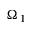Convert formula to latex. <formula><loc_0><loc_0><loc_500><loc_500>\Omega _ { 1 }</formula> 